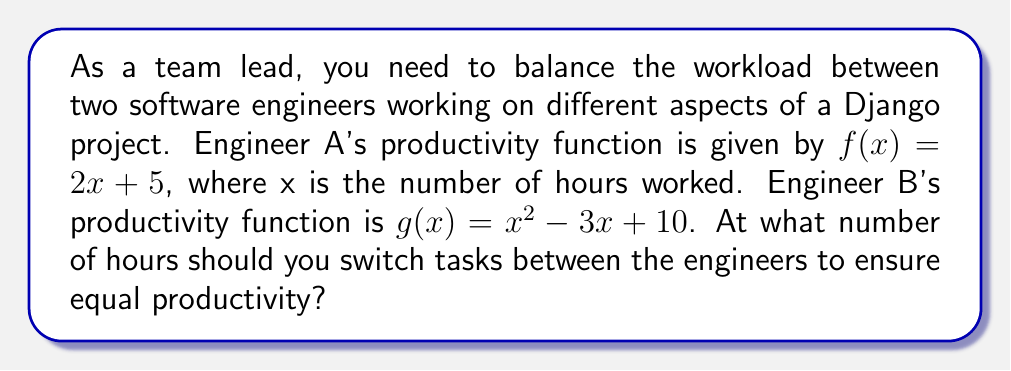Solve this math problem. To find the point where the engineers' productivity is equal, we need to find the intersection of their productivity functions. This involves solving the equation:

$$f(x) = g(x)$$

Step 1: Substitute the given functions into the equation
$$2x + 5 = x^2 - 3x + 10$$

Step 2: Rearrange the equation to standard quadratic form
$$x^2 - 5x + 5 = 0$$

Step 3: Solve the quadratic equation using the quadratic formula
$$x = \frac{-b \pm \sqrt{b^2 - 4ac}}{2a}$$

Where $a = 1$, $b = -5$, and $c = 5$

$$x = \frac{5 \pm \sqrt{25 - 20}}{2} = \frac{5 \pm \sqrt{5}}{2}$$

Step 4: Simplify the solution
$$x = \frac{5 + \sqrt{5}}{2} \approx 3.618$$ (positive root)
$$x = \frac{5 - \sqrt{5}}{2} \approx 1.382$$ (negative root)

Since we're dealing with hours worked, we'll use the positive root.

Step 5: Round to the nearest quarter hour for practical application
$$3.618 \approx 3.62 \approx 3\text{ hours and }37\text{ minutes}$$
Answer: $3\text{ hours and }37\text{ minutes}$ 